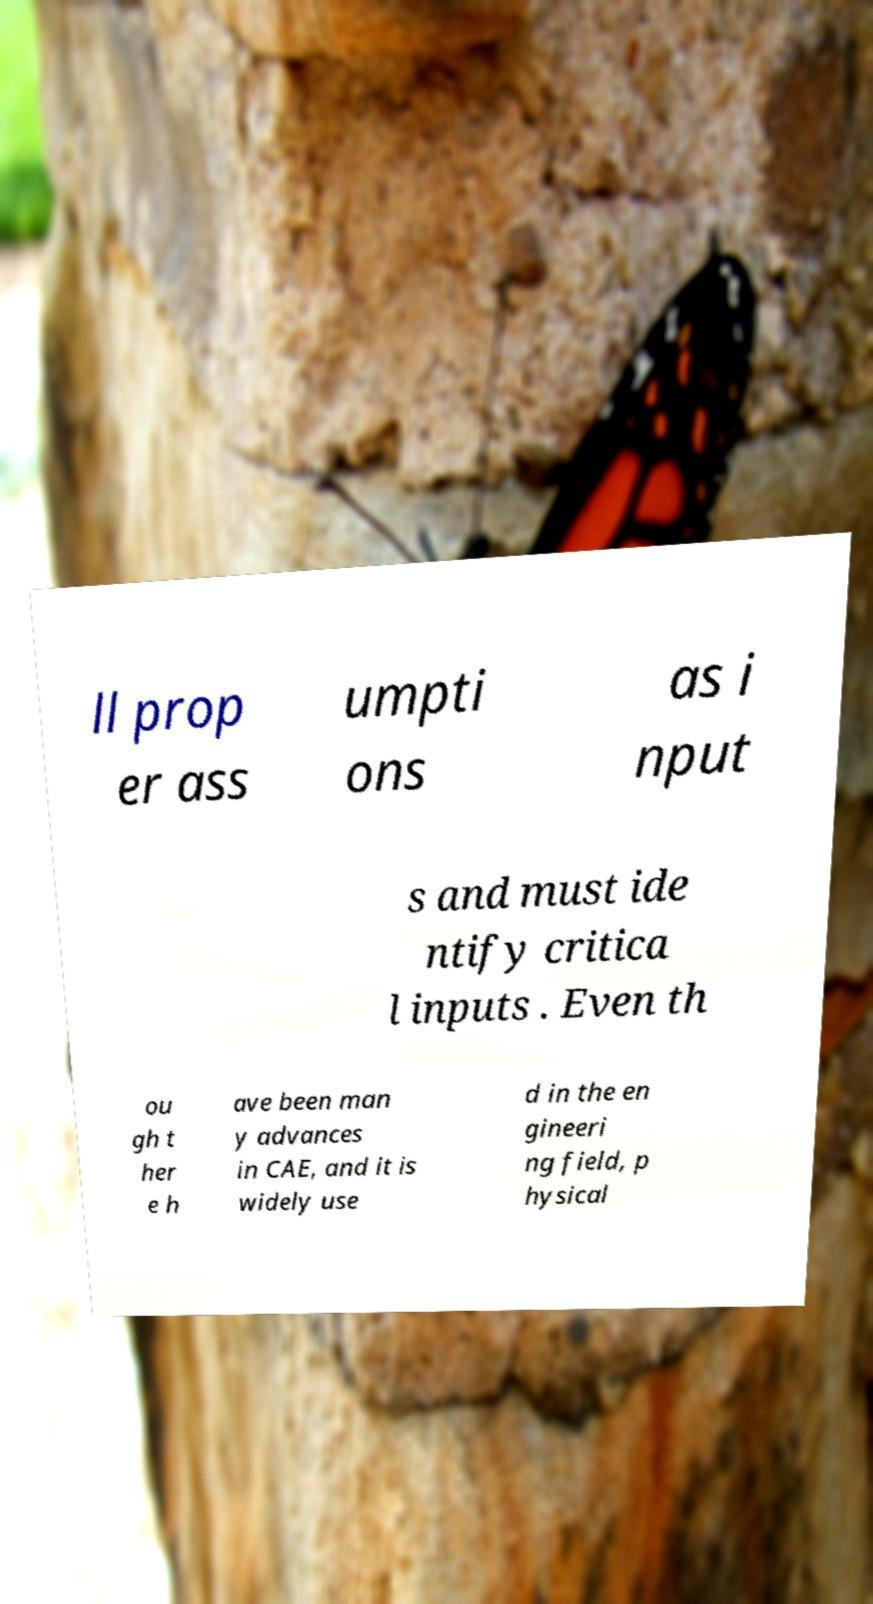For documentation purposes, I need the text within this image transcribed. Could you provide that? ll prop er ass umpti ons as i nput s and must ide ntify critica l inputs . Even th ou gh t her e h ave been man y advances in CAE, and it is widely use d in the en gineeri ng field, p hysical 